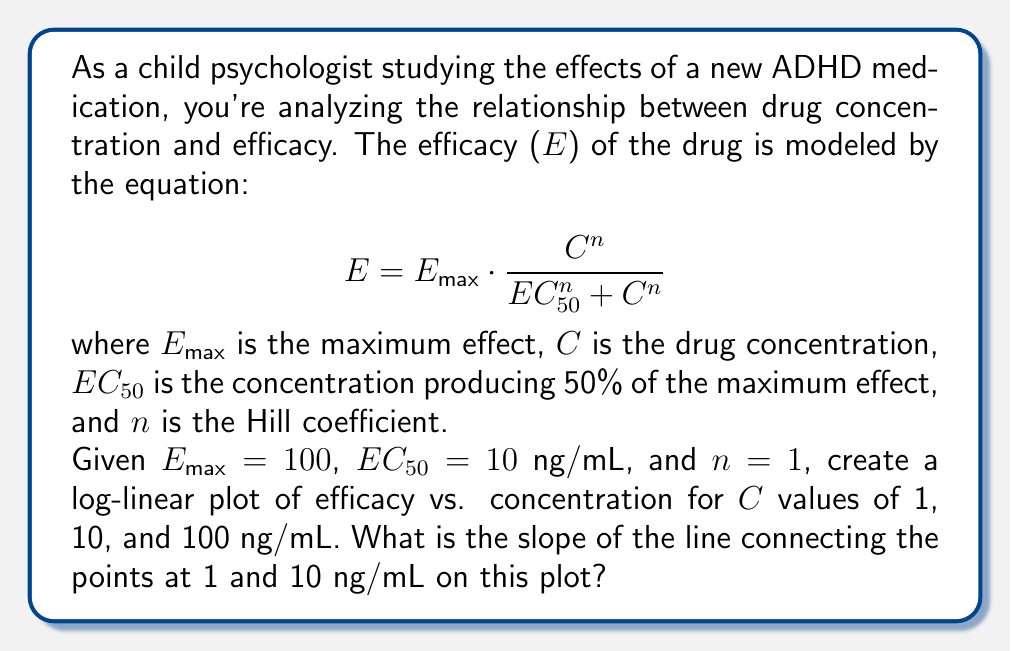Could you help me with this problem? To solve this problem, we need to follow these steps:

1) Calculate the efficacy (E) for each concentration using the given equation.
2) Create a log-linear plot by taking the logarithm of concentration values.
3) Calculate the slope between the points at 1 and 10 ng/mL.

Step 1: Calculate efficacy values

For $C = 1$ ng/mL:
$E = 100 \cdot \frac{1^1}{10^1 + 1^1} = 100 \cdot \frac{1}{11} = 9.09$

For $C = 10$ ng/mL:
$E = 100 \cdot \frac{10^1}{10^1 + 10^1} = 100 \cdot \frac{10}{20} = 50$

For $C = 100$ ng/mL:
$E = 100 \cdot \frac{100^1}{10^1 + 100^1} = 100 \cdot \frac{100}{110} = 90.91$

Step 2: Create log-linear plot

We take the logarithm (base 10) of concentration values:
$\log(1) = 0$
$\log(10) = 1$
$\log(100) = 2$

Our plot points are now:
(0, 9.09)
(1, 50)
(2, 90.91)

Step 3: Calculate slope

The slope between the points (0, 9.09) and (1, 50) is:

$\text{slope} = \frac{y_2 - y_1}{x_2 - x_1} = \frac{50 - 9.09}{1 - 0} = 40.91$

Therefore, the slope of the line connecting the points at 1 and 10 ng/mL on the log-linear plot is 40.91.
Answer: 40.91 